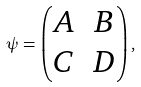<formula> <loc_0><loc_0><loc_500><loc_500>\psi = \begin{pmatrix} A & B \\ C & D \end{pmatrix} ,</formula> 